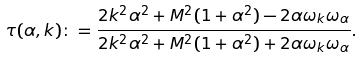Convert formula to latex. <formula><loc_0><loc_0><loc_500><loc_500>\tau ( \alpha , k ) \colon = \frac { 2 k ^ { 2 } \alpha ^ { 2 } + M ^ { 2 } ( 1 + \alpha ^ { 2 } ) - 2 \alpha \omega _ { k } \omega _ { \alpha } } { 2 k ^ { 2 } \alpha ^ { 2 } + M ^ { 2 } ( 1 + \alpha ^ { 2 } ) + 2 \alpha \omega _ { k } \omega _ { \alpha } } .</formula> 